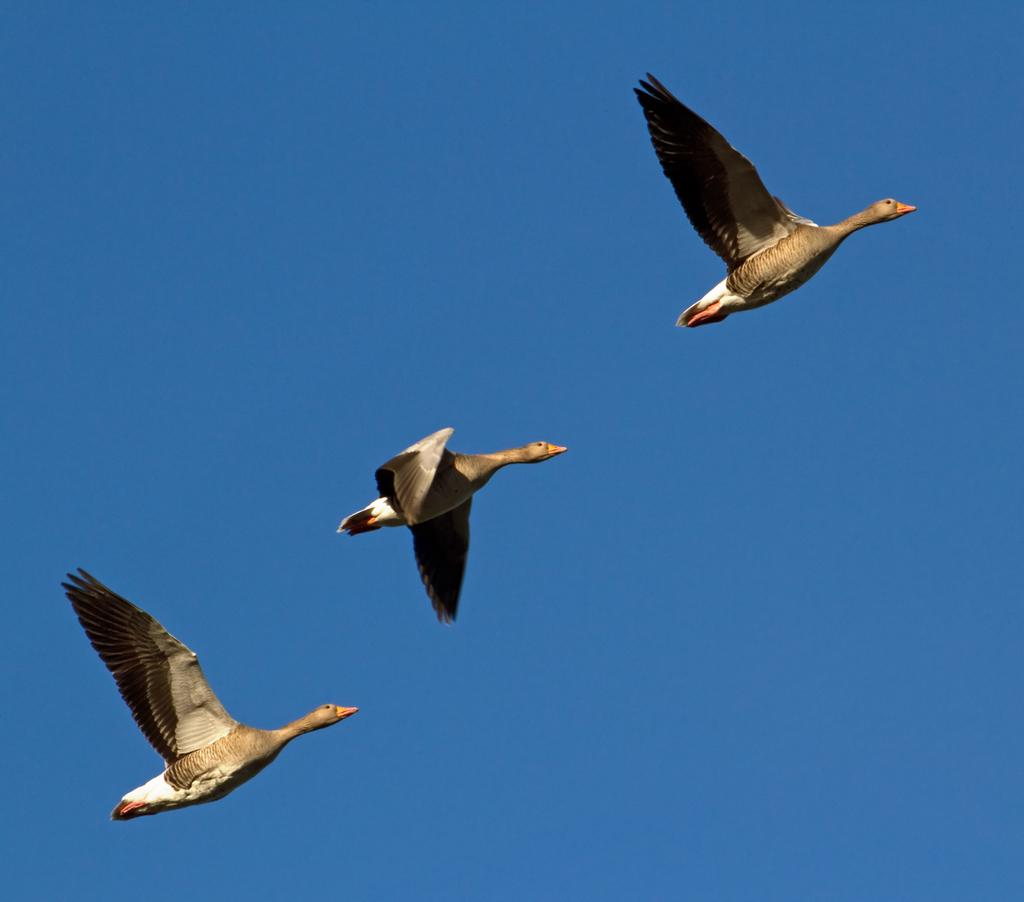Where was the image taken? The image was taken outdoors. What can be seen in the background of the image? There is a sky visible in the background of the image. What is happening in the sky in the image? Three birds are flying in the sky. What type of bottle is being used as a representative in the image? There is no bottle present in the image, and therefore no representative role for a bottle. 